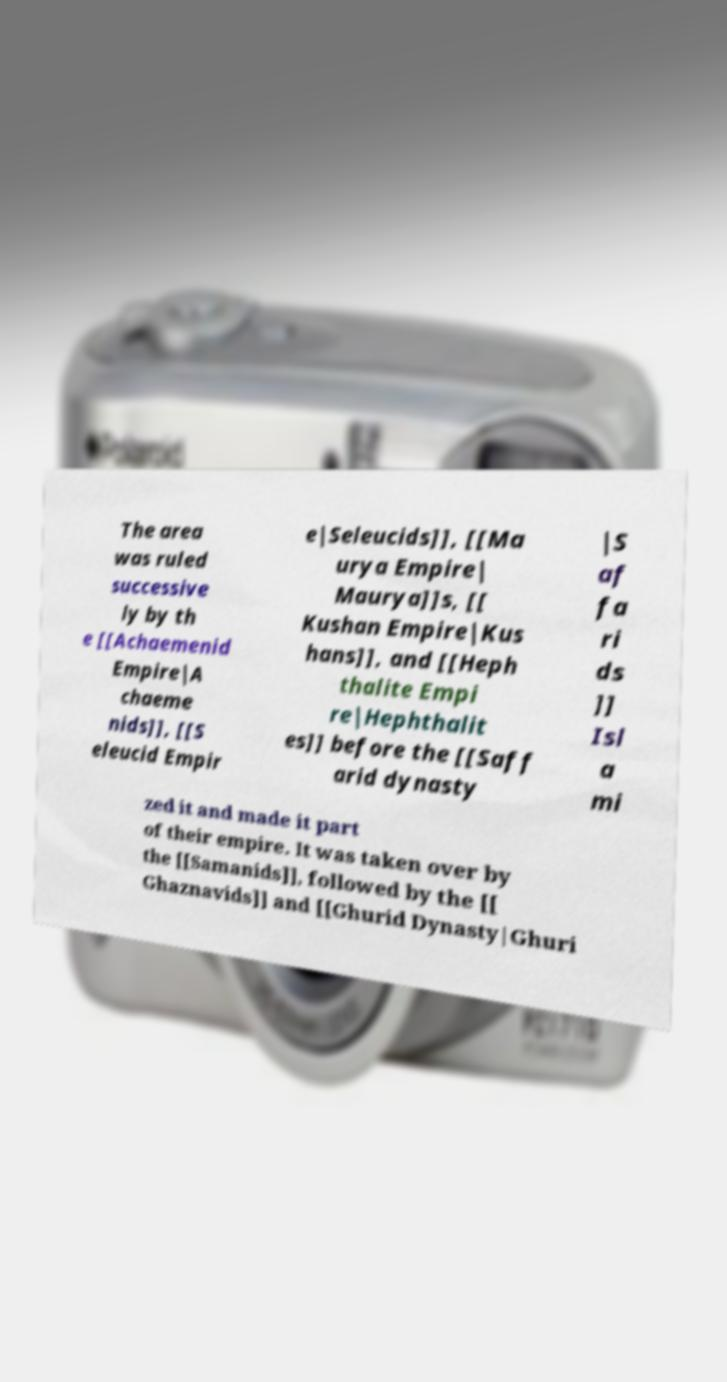Can you accurately transcribe the text from the provided image for me? The area was ruled successive ly by th e [[Achaemenid Empire|A chaeme nids]], [[S eleucid Empir e|Seleucids]], [[Ma urya Empire| Maurya]]s, [[ Kushan Empire|Kus hans]], and [[Heph thalite Empi re|Hephthalit es]] before the [[Saff arid dynasty |S af fa ri ds ]] Isl a mi zed it and made it part of their empire. It was taken over by the [[Samanids]], followed by the [[ Ghaznavids]] and [[Ghurid Dynasty|Ghuri 